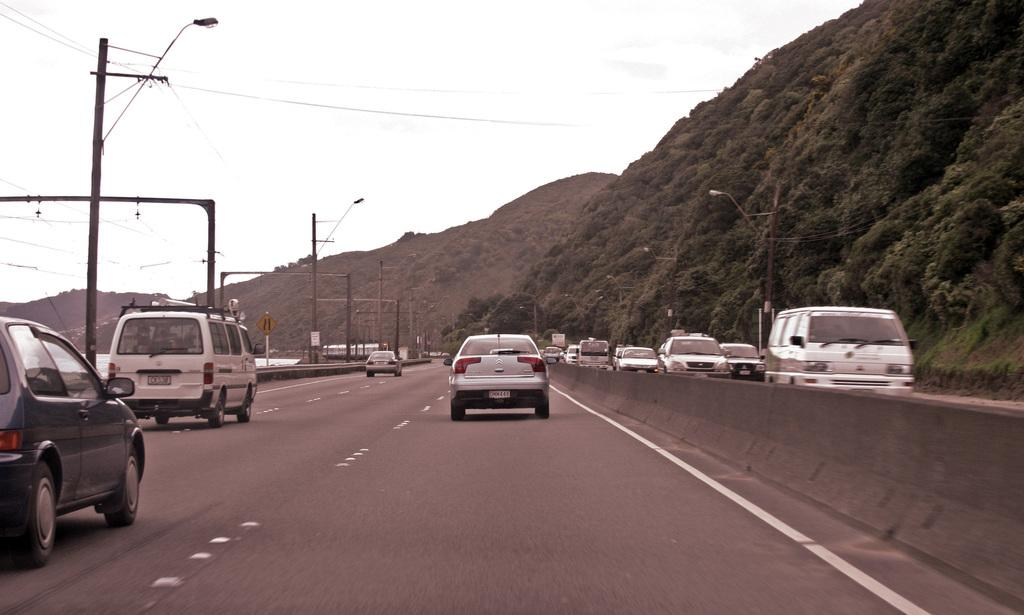What can be seen moving in the image? There are vehicles in the image, which suggests they are moving. What is the surface on which the vehicles are moving? There is a road in the image, which is the surface on which the vehicles are moving. What separates the road into two lanes? There is a road divider in the image, which separates the road into two lanes. What are the poles supporting in the image? The poles are supporting wires in the image. What natural features can be seen in the background of the image? There are mountains, grass, trees, and the sky visible in the image. What might be used for providing directions or information in the image? There are signboards in the image, which might be used for providing directions or information. What type of building can be seen in the image? There is no building present in the image. What direction is the person walking in the image? There is no person walking in the image. What scale is used to measure the size of the trees in the image? There is no scale present in the image to measure the size of the trees. 